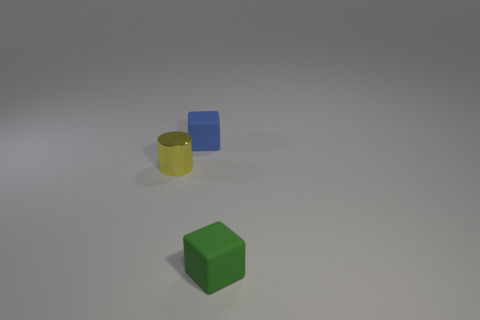There is a tiny object to the left of the small block that is behind the tiny yellow shiny cylinder; what number of yellow cylinders are on the left side of it? In the image provided, the composition predominantly includes geometric objects. Regarding the yellow cylinder, there are no additional yellow cylinders positioned to its left side. 